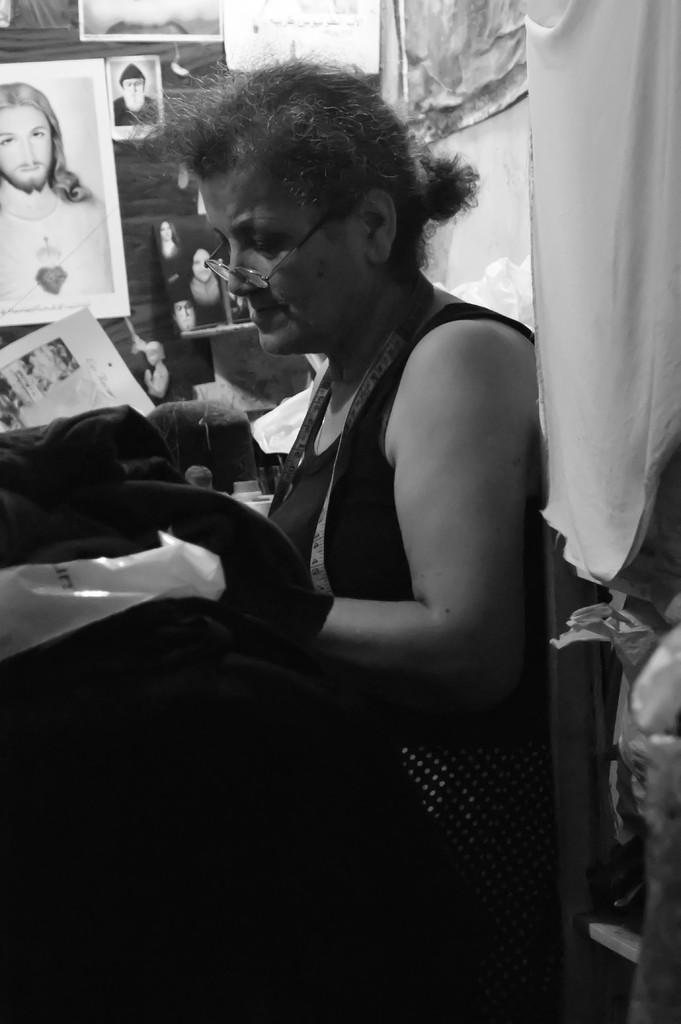What is the person in the image doing? There is a person sitting in the image. What is the person holding? The person is holding an object. What can be seen on the wall in the background? There are frames on the wall in the background. What is located on the right side of the image? There is a cloth on the right side of the image. What type of items are present in the image? There are papers in the image. What type of toy can be seen in the person's hand in the image? There is no toy present in the person's hand in the image. What type of drink is the person holding in the image? The person is not holding a drink in the image; they are holding an object. 